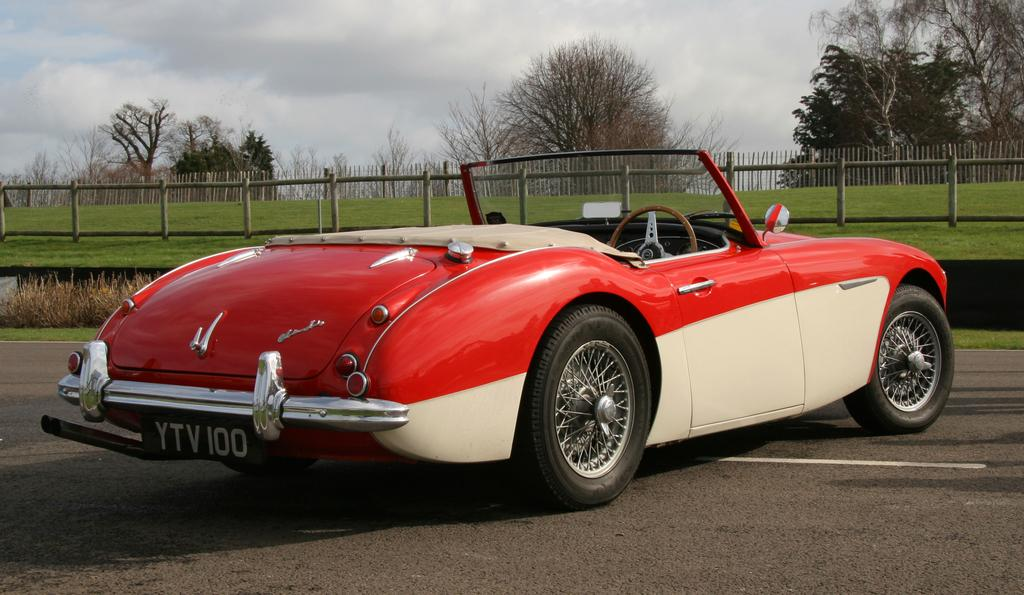What is the main subject in the middle of the image? There is a car in the middle of the image. What can be seen in the background of the image? There is a wooden fence, an iron grill, and trees visible in the background of the image. What is visible at the top of the image? The sky is visible at the top of the image. Can you tell me how many bones the stranger is holding in the image? There is no stranger or bones present in the image. What achievements has the achiever accomplished in the image? There is no achiever or achievements depicted in the image. 